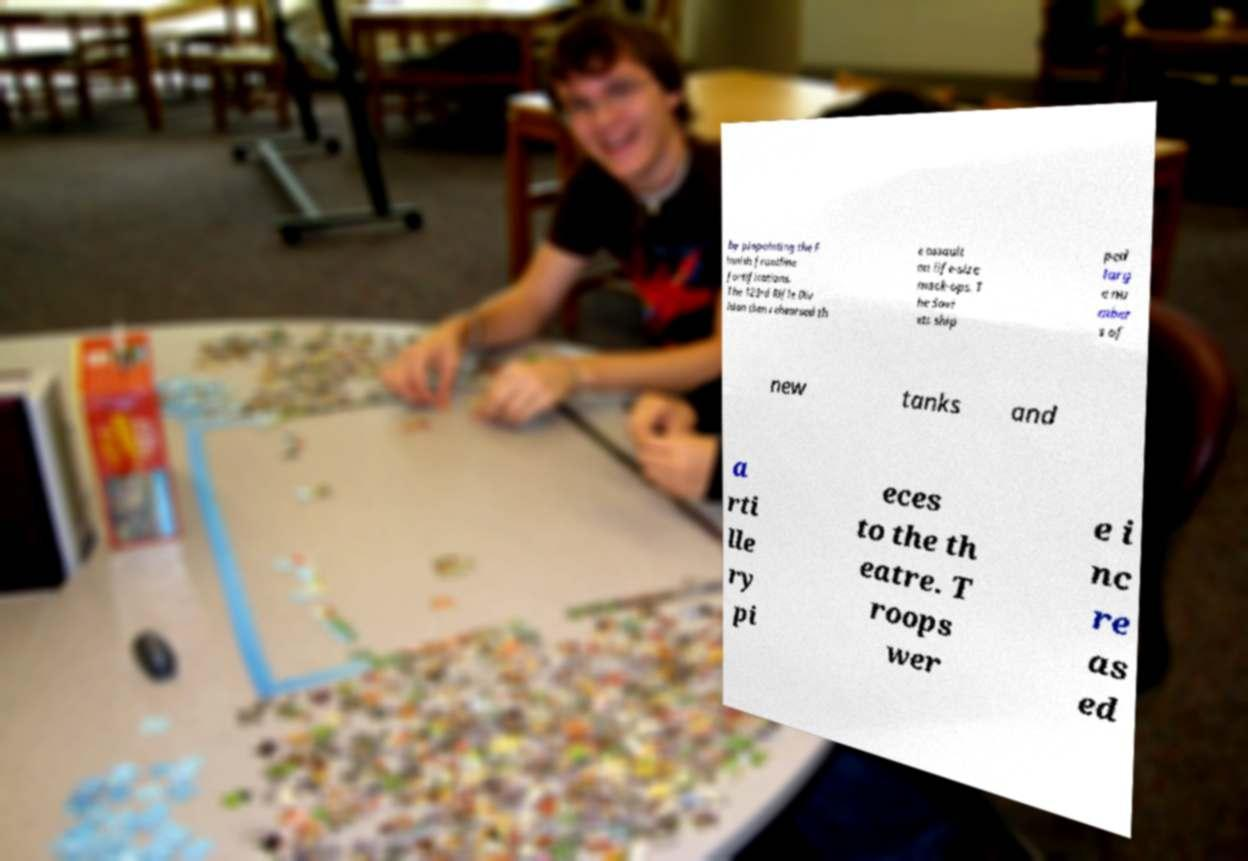Can you accurately transcribe the text from the provided image for me? by pinpointing the F innish frontline fortifications. The 123rd Rifle Div ision then rehearsed th e assault on life-size mock-ups. T he Sovi ets ship ped larg e nu mber s of new tanks and a rti lle ry pi eces to the th eatre. T roops wer e i nc re as ed 